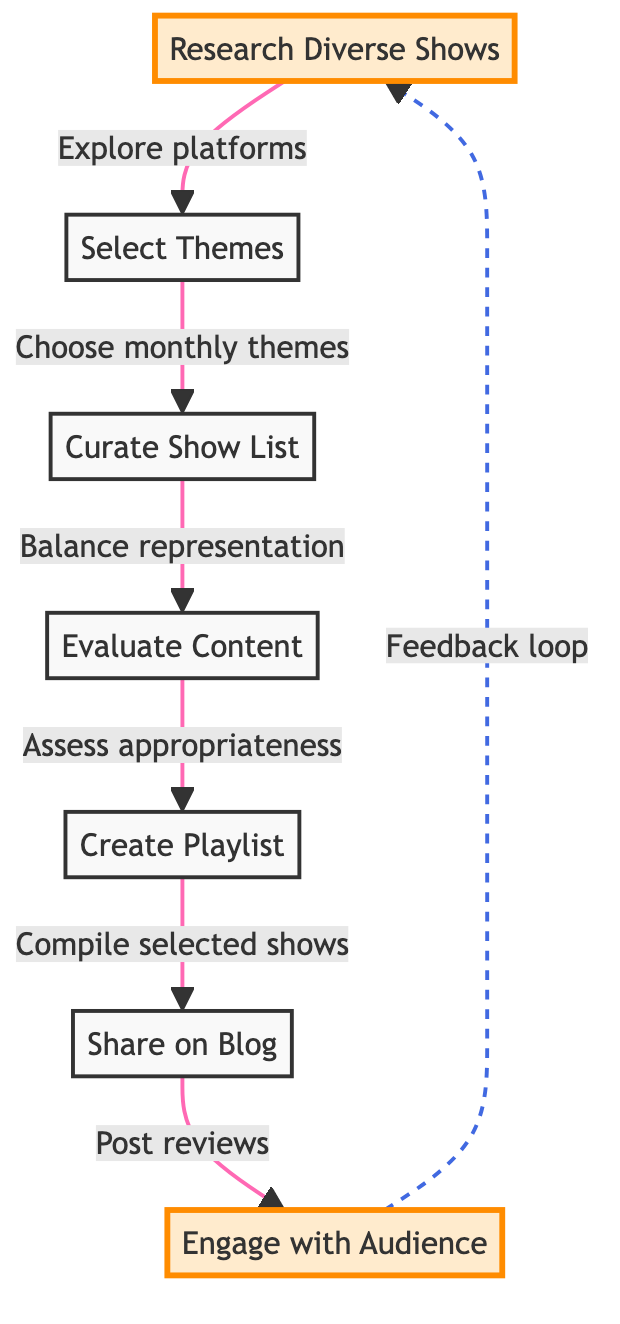What is the first step in creating a monthly playlist? The first step is "Research Diverse Shows," which involves exploring platforms for shows.
Answer: Research Diverse Shows How many steps are there in the process? There are a total of seven steps in the process, counting each individual node in the flowchart.
Answer: Seven What follows the selection of themes? After selecting themes, the next step is to "Curate Show List."
Answer: Curate Show List What is the final step in the flowchart? The last step in the flowchart is "Engage with Audience," which encourages feedback from readers.
Answer: Engage with Audience Which step includes posting reviews? The step where posting reviews occurs is "Share on Blog."
Answer: Share on Blog What relationship exists between "Evaluate Content" and "Create Playlist"? "Evaluate Content" leads directly to "Create Playlist," indicating that show evaluation is necessary before compiling.
Answer: Direct relationship How does feedback loop back into the process? The feedback from the audience connects back to "Research Diverse Shows," implying continuous improvement.
Answer: Continuous improvement What type of flow connects "Share on Blog" and "Engage with Audience"? The flow between "Share on Blog" and "Engage with Audience" is represented by a dashed line, indicating a feedback or less formal connection.
Answer: Dashed line What indicates that the shows should have balanced representation? The step "Curate Show List" states the need for balance in representation when creating the list of shows.
Answer: Balance of representation 